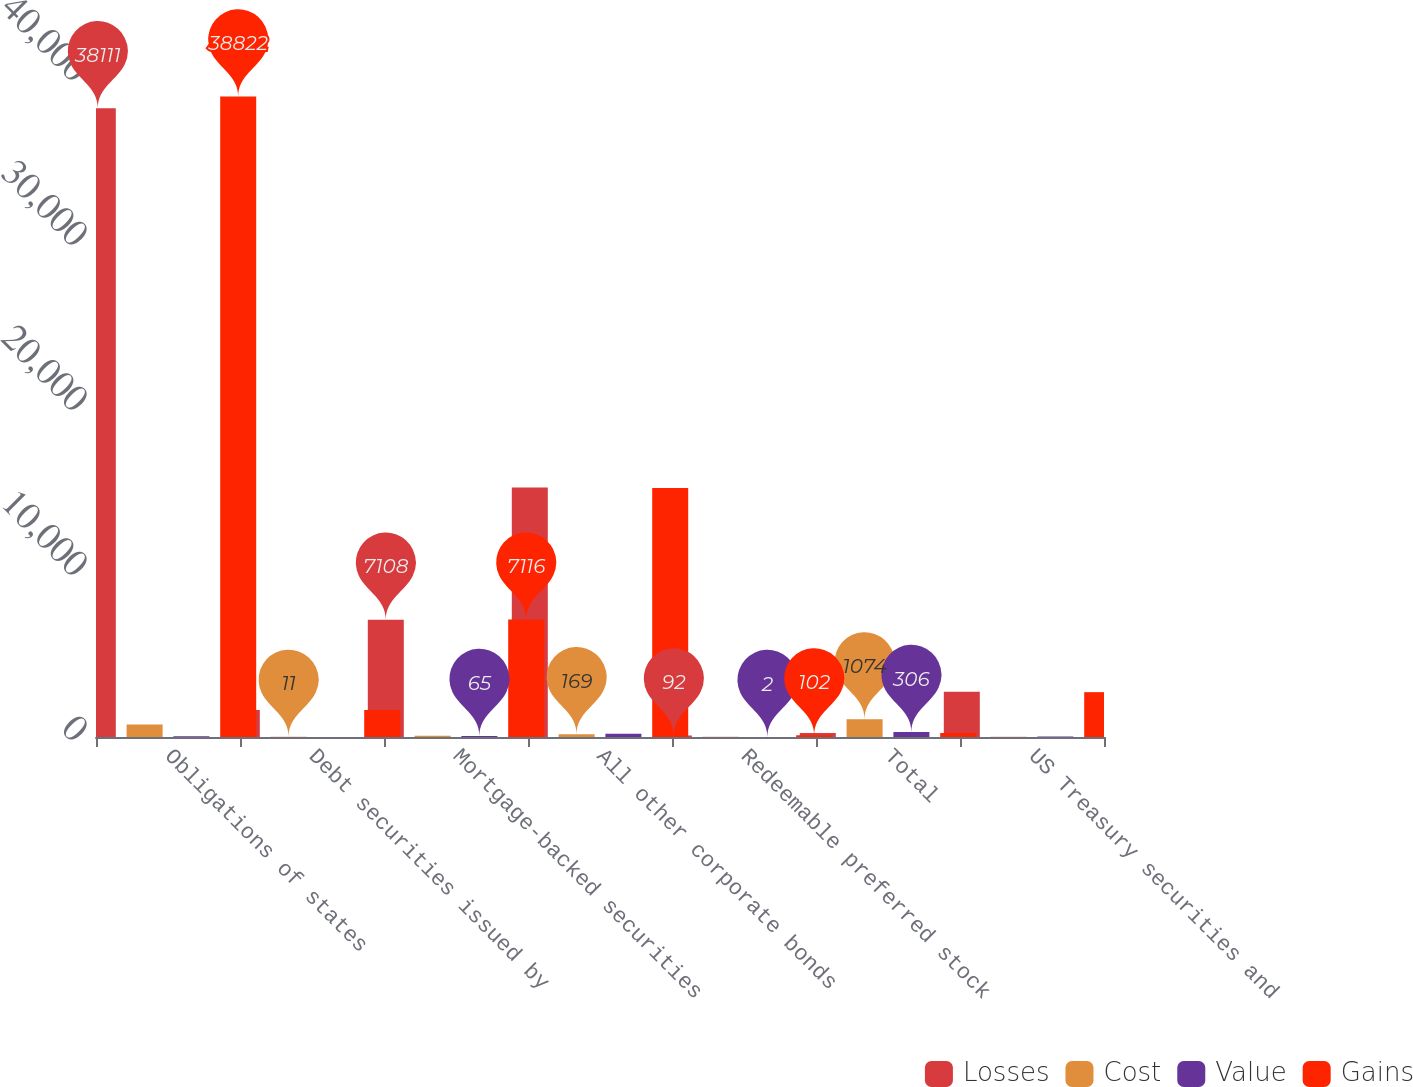Convert chart to OTSL. <chart><loc_0><loc_0><loc_500><loc_500><stacked_bar_chart><ecel><fcel>Obligations of states<fcel>Debt securities issued by<fcel>Mortgage-backed securities<fcel>All other corporate bonds<fcel>Redeemable preferred stock<fcel>Total<fcel>US Treasury securities and<nl><fcel>Losses<fcel>38111<fcel>1629<fcel>7108<fcel>15120<fcel>92<fcel>250<fcel>2736<nl><fcel>Cost<fcel>751<fcel>11<fcel>73<fcel>169<fcel>12<fcel>1074<fcel>13<nl><fcel>Value<fcel>40<fcel>5<fcel>65<fcel>194<fcel>2<fcel>306<fcel>31<nl><fcel>Gains<fcel>38822<fcel>1635<fcel>7116<fcel>15095<fcel>102<fcel>250<fcel>2718<nl></chart> 